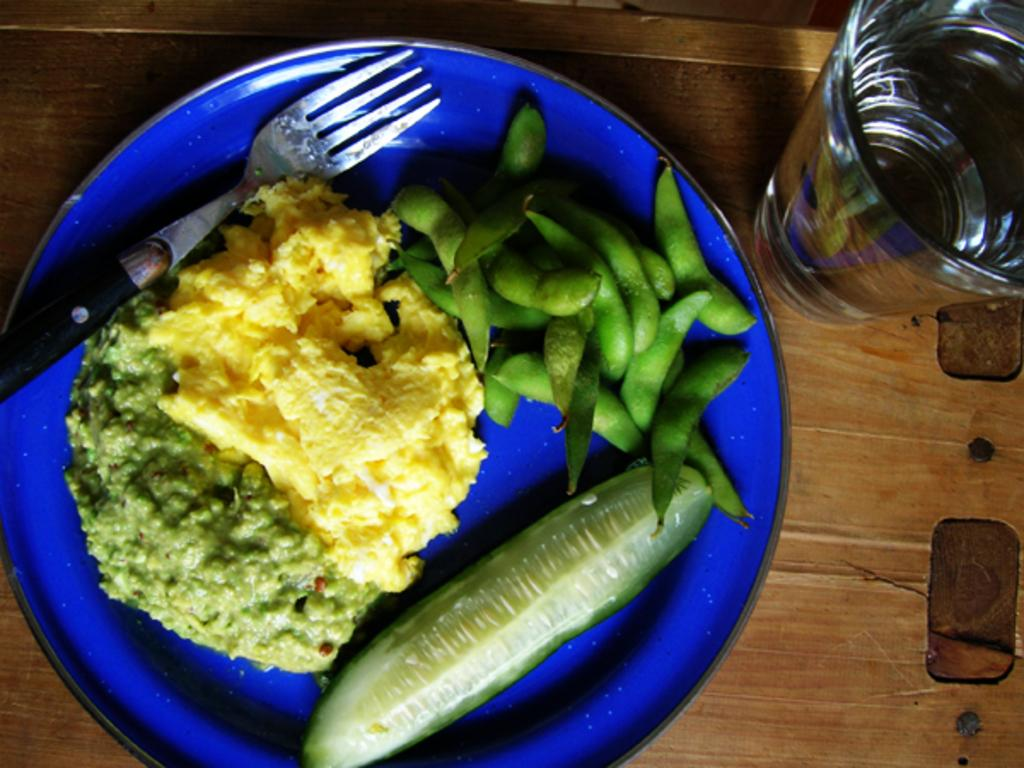What type of objects can be seen in the image? There are food items, a fork on a plate, a glass, and a plate on a table visible in the image. What is the purpose of the fork in the image? The fork is on a plate, which suggests it is being used to eat the food items. What is contained in the glass in the image? Water is visible in the glass. What type of yarn is being used to create the thunderstorm in the image? There is no thunderstorm or yarn present in the image; it features food items, a fork, a plate, and a glass. 